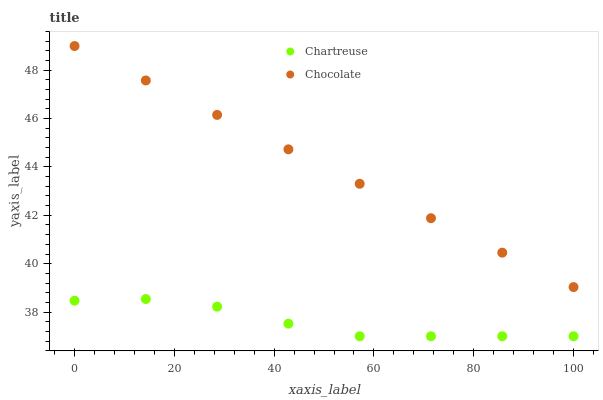Does Chartreuse have the minimum area under the curve?
Answer yes or no. Yes. Does Chocolate have the maximum area under the curve?
Answer yes or no. Yes. Does Chocolate have the minimum area under the curve?
Answer yes or no. No. Is Chocolate the smoothest?
Answer yes or no. Yes. Is Chartreuse the roughest?
Answer yes or no. Yes. Is Chocolate the roughest?
Answer yes or no. No. Does Chartreuse have the lowest value?
Answer yes or no. Yes. Does Chocolate have the lowest value?
Answer yes or no. No. Does Chocolate have the highest value?
Answer yes or no. Yes. Is Chartreuse less than Chocolate?
Answer yes or no. Yes. Is Chocolate greater than Chartreuse?
Answer yes or no. Yes. Does Chartreuse intersect Chocolate?
Answer yes or no. No. 